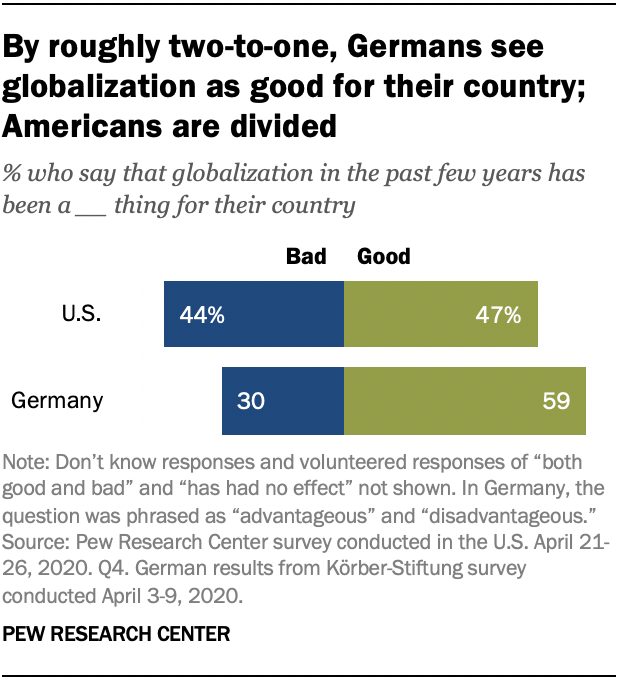Draw attention to some important aspects in this diagram. According to the survey, only 0.09% of US respondents had no opinion on the issue in question. The data represented is from the year 2020. 